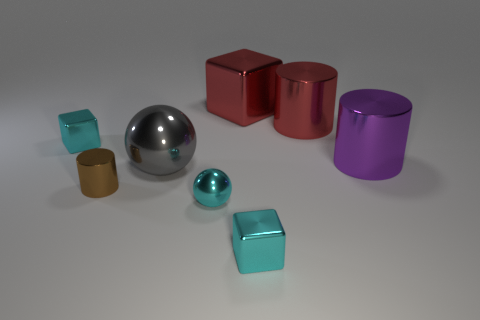How many other things are the same shape as the small brown thing?
Your response must be concise. 2. What shape is the big purple thing that is made of the same material as the small brown thing?
Provide a succinct answer. Cylinder. The cylinder that is on the left side of the purple object and right of the big red metallic block is what color?
Ensure brevity in your answer.  Red. Does the large red object right of the large red cube have the same material as the tiny brown thing?
Ensure brevity in your answer.  Yes. Are there fewer tiny cyan things that are in front of the purple metallic cylinder than big purple metallic objects?
Give a very brief answer. No. Is there a tiny ball that has the same material as the small cylinder?
Provide a short and direct response. Yes. Do the gray object and the cube that is to the left of the red cube have the same size?
Provide a succinct answer. No. Is there a small metallic cylinder of the same color as the small ball?
Make the answer very short. No. Do the large red cylinder and the big gray sphere have the same material?
Your answer should be very brief. Yes. How many gray metallic objects are in front of the gray metallic object?
Keep it short and to the point. 0. 